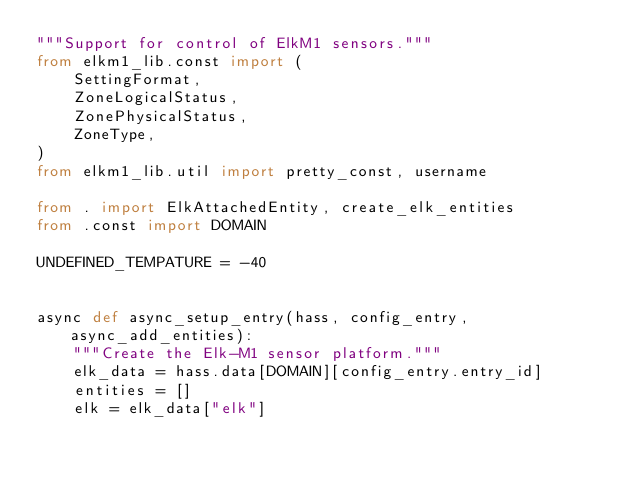Convert code to text. <code><loc_0><loc_0><loc_500><loc_500><_Python_>"""Support for control of ElkM1 sensors."""
from elkm1_lib.const import (
    SettingFormat,
    ZoneLogicalStatus,
    ZonePhysicalStatus,
    ZoneType,
)
from elkm1_lib.util import pretty_const, username

from . import ElkAttachedEntity, create_elk_entities
from .const import DOMAIN

UNDEFINED_TEMPATURE = -40


async def async_setup_entry(hass, config_entry, async_add_entities):
    """Create the Elk-M1 sensor platform."""
    elk_data = hass.data[DOMAIN][config_entry.entry_id]
    entities = []
    elk = elk_data["elk"]</code> 